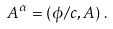<formula> <loc_0><loc_0><loc_500><loc_500>A ^ { \alpha } = \left ( \phi / c , A \right ) \, .</formula> 